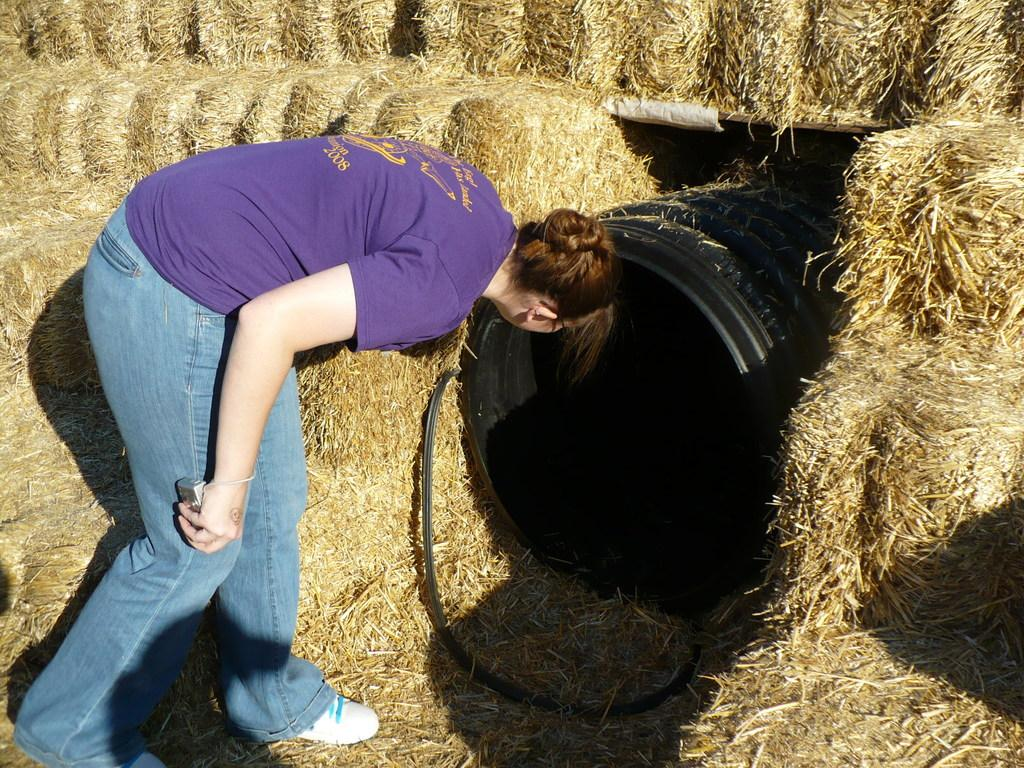Who is present in the image? There is a woman in the image. What is the woman looking at? The woman is looking at a black color object. What type of natural environment is visible in the image? Dried grass is visible in the image. How many bridges can be seen in the image? There are no bridges present in the image. What type of can is visible in the image? There is no can present in the image. 